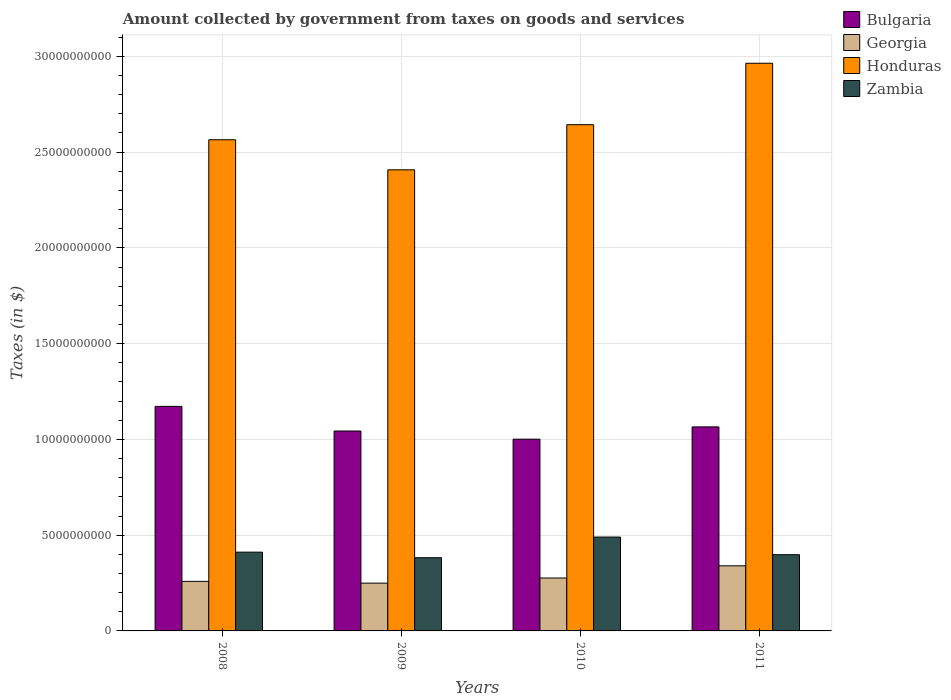How many different coloured bars are there?
Make the answer very short. 4. How many bars are there on the 4th tick from the left?
Offer a very short reply. 4. In how many cases, is the number of bars for a given year not equal to the number of legend labels?
Provide a succinct answer. 0. What is the amount collected by government from taxes on goods and services in Georgia in 2011?
Your answer should be very brief. 3.40e+09. Across all years, what is the maximum amount collected by government from taxes on goods and services in Zambia?
Offer a very short reply. 4.90e+09. Across all years, what is the minimum amount collected by government from taxes on goods and services in Honduras?
Ensure brevity in your answer.  2.41e+1. In which year was the amount collected by government from taxes on goods and services in Georgia maximum?
Keep it short and to the point. 2011. In which year was the amount collected by government from taxes on goods and services in Bulgaria minimum?
Provide a succinct answer. 2010. What is the total amount collected by government from taxes on goods and services in Bulgaria in the graph?
Your answer should be compact. 4.28e+1. What is the difference between the amount collected by government from taxes on goods and services in Honduras in 2008 and that in 2011?
Your response must be concise. -3.99e+09. What is the difference between the amount collected by government from taxes on goods and services in Honduras in 2011 and the amount collected by government from taxes on goods and services in Georgia in 2008?
Provide a succinct answer. 2.71e+1. What is the average amount collected by government from taxes on goods and services in Georgia per year?
Ensure brevity in your answer.  2.81e+09. In the year 2009, what is the difference between the amount collected by government from taxes on goods and services in Zambia and amount collected by government from taxes on goods and services in Bulgaria?
Your answer should be compact. -6.62e+09. In how many years, is the amount collected by government from taxes on goods and services in Georgia greater than 14000000000 $?
Ensure brevity in your answer.  0. What is the ratio of the amount collected by government from taxes on goods and services in Zambia in 2010 to that in 2011?
Make the answer very short. 1.23. What is the difference between the highest and the second highest amount collected by government from taxes on goods and services in Honduras?
Provide a succinct answer. 3.21e+09. What is the difference between the highest and the lowest amount collected by government from taxes on goods and services in Honduras?
Make the answer very short. 5.56e+09. Is it the case that in every year, the sum of the amount collected by government from taxes on goods and services in Georgia and amount collected by government from taxes on goods and services in Honduras is greater than the sum of amount collected by government from taxes on goods and services in Bulgaria and amount collected by government from taxes on goods and services in Zambia?
Provide a succinct answer. Yes. What does the 3rd bar from the left in 2011 represents?
Provide a short and direct response. Honduras. What does the 3rd bar from the right in 2011 represents?
Your response must be concise. Georgia. Is it the case that in every year, the sum of the amount collected by government from taxes on goods and services in Bulgaria and amount collected by government from taxes on goods and services in Georgia is greater than the amount collected by government from taxes on goods and services in Zambia?
Your response must be concise. Yes. Are all the bars in the graph horizontal?
Your answer should be very brief. No. How many years are there in the graph?
Offer a very short reply. 4. What is the difference between two consecutive major ticks on the Y-axis?
Provide a succinct answer. 5.00e+09. Does the graph contain any zero values?
Ensure brevity in your answer.  No. Where does the legend appear in the graph?
Give a very brief answer. Top right. How many legend labels are there?
Keep it short and to the point. 4. What is the title of the graph?
Offer a terse response. Amount collected by government from taxes on goods and services. What is the label or title of the Y-axis?
Give a very brief answer. Taxes (in $). What is the Taxes (in $) of Bulgaria in 2008?
Give a very brief answer. 1.17e+1. What is the Taxes (in $) of Georgia in 2008?
Your answer should be compact. 2.59e+09. What is the Taxes (in $) in Honduras in 2008?
Make the answer very short. 2.56e+1. What is the Taxes (in $) in Zambia in 2008?
Give a very brief answer. 4.11e+09. What is the Taxes (in $) in Bulgaria in 2009?
Offer a terse response. 1.04e+1. What is the Taxes (in $) of Georgia in 2009?
Your answer should be very brief. 2.49e+09. What is the Taxes (in $) of Honduras in 2009?
Your response must be concise. 2.41e+1. What is the Taxes (in $) of Zambia in 2009?
Your answer should be very brief. 3.82e+09. What is the Taxes (in $) in Bulgaria in 2010?
Make the answer very short. 1.00e+1. What is the Taxes (in $) of Georgia in 2010?
Offer a very short reply. 2.76e+09. What is the Taxes (in $) in Honduras in 2010?
Make the answer very short. 2.64e+1. What is the Taxes (in $) in Zambia in 2010?
Ensure brevity in your answer.  4.90e+09. What is the Taxes (in $) of Bulgaria in 2011?
Offer a very short reply. 1.07e+1. What is the Taxes (in $) in Georgia in 2011?
Your answer should be very brief. 3.40e+09. What is the Taxes (in $) of Honduras in 2011?
Keep it short and to the point. 2.96e+1. What is the Taxes (in $) in Zambia in 2011?
Ensure brevity in your answer.  3.98e+09. Across all years, what is the maximum Taxes (in $) in Bulgaria?
Give a very brief answer. 1.17e+1. Across all years, what is the maximum Taxes (in $) in Georgia?
Your response must be concise. 3.40e+09. Across all years, what is the maximum Taxes (in $) in Honduras?
Your answer should be very brief. 2.96e+1. Across all years, what is the maximum Taxes (in $) of Zambia?
Provide a succinct answer. 4.90e+09. Across all years, what is the minimum Taxes (in $) of Bulgaria?
Your answer should be compact. 1.00e+1. Across all years, what is the minimum Taxes (in $) of Georgia?
Ensure brevity in your answer.  2.49e+09. Across all years, what is the minimum Taxes (in $) of Honduras?
Make the answer very short. 2.41e+1. Across all years, what is the minimum Taxes (in $) of Zambia?
Offer a very short reply. 3.82e+09. What is the total Taxes (in $) of Bulgaria in the graph?
Keep it short and to the point. 4.28e+1. What is the total Taxes (in $) of Georgia in the graph?
Keep it short and to the point. 1.12e+1. What is the total Taxes (in $) in Honduras in the graph?
Ensure brevity in your answer.  1.06e+11. What is the total Taxes (in $) in Zambia in the graph?
Provide a short and direct response. 1.68e+1. What is the difference between the Taxes (in $) in Bulgaria in 2008 and that in 2009?
Keep it short and to the point. 1.29e+09. What is the difference between the Taxes (in $) of Georgia in 2008 and that in 2009?
Ensure brevity in your answer.  9.26e+07. What is the difference between the Taxes (in $) of Honduras in 2008 and that in 2009?
Offer a very short reply. 1.57e+09. What is the difference between the Taxes (in $) in Zambia in 2008 and that in 2009?
Give a very brief answer. 2.91e+08. What is the difference between the Taxes (in $) of Bulgaria in 2008 and that in 2010?
Provide a succinct answer. 1.71e+09. What is the difference between the Taxes (in $) in Georgia in 2008 and that in 2010?
Ensure brevity in your answer.  -1.76e+08. What is the difference between the Taxes (in $) in Honduras in 2008 and that in 2010?
Give a very brief answer. -7.85e+08. What is the difference between the Taxes (in $) of Zambia in 2008 and that in 2010?
Provide a short and direct response. -7.88e+08. What is the difference between the Taxes (in $) in Bulgaria in 2008 and that in 2011?
Your answer should be very brief. 1.07e+09. What is the difference between the Taxes (in $) in Georgia in 2008 and that in 2011?
Give a very brief answer. -8.12e+08. What is the difference between the Taxes (in $) in Honduras in 2008 and that in 2011?
Give a very brief answer. -3.99e+09. What is the difference between the Taxes (in $) in Zambia in 2008 and that in 2011?
Ensure brevity in your answer.  1.33e+08. What is the difference between the Taxes (in $) of Bulgaria in 2009 and that in 2010?
Your answer should be very brief. 4.26e+08. What is the difference between the Taxes (in $) of Georgia in 2009 and that in 2010?
Give a very brief answer. -2.69e+08. What is the difference between the Taxes (in $) of Honduras in 2009 and that in 2010?
Your answer should be very brief. -2.36e+09. What is the difference between the Taxes (in $) in Zambia in 2009 and that in 2010?
Your answer should be compact. -1.08e+09. What is the difference between the Taxes (in $) of Bulgaria in 2009 and that in 2011?
Provide a short and direct response. -2.15e+08. What is the difference between the Taxes (in $) in Georgia in 2009 and that in 2011?
Offer a very short reply. -9.05e+08. What is the difference between the Taxes (in $) in Honduras in 2009 and that in 2011?
Make the answer very short. -5.56e+09. What is the difference between the Taxes (in $) of Zambia in 2009 and that in 2011?
Ensure brevity in your answer.  -1.58e+08. What is the difference between the Taxes (in $) in Bulgaria in 2010 and that in 2011?
Ensure brevity in your answer.  -6.41e+08. What is the difference between the Taxes (in $) of Georgia in 2010 and that in 2011?
Keep it short and to the point. -6.36e+08. What is the difference between the Taxes (in $) of Honduras in 2010 and that in 2011?
Offer a terse response. -3.21e+09. What is the difference between the Taxes (in $) in Zambia in 2010 and that in 2011?
Keep it short and to the point. 9.21e+08. What is the difference between the Taxes (in $) in Bulgaria in 2008 and the Taxes (in $) in Georgia in 2009?
Provide a short and direct response. 9.23e+09. What is the difference between the Taxes (in $) of Bulgaria in 2008 and the Taxes (in $) of Honduras in 2009?
Your answer should be very brief. -1.24e+1. What is the difference between the Taxes (in $) in Bulgaria in 2008 and the Taxes (in $) in Zambia in 2009?
Your response must be concise. 7.90e+09. What is the difference between the Taxes (in $) of Georgia in 2008 and the Taxes (in $) of Honduras in 2009?
Make the answer very short. -2.15e+1. What is the difference between the Taxes (in $) of Georgia in 2008 and the Taxes (in $) of Zambia in 2009?
Keep it short and to the point. -1.23e+09. What is the difference between the Taxes (in $) of Honduras in 2008 and the Taxes (in $) of Zambia in 2009?
Give a very brief answer. 2.18e+1. What is the difference between the Taxes (in $) of Bulgaria in 2008 and the Taxes (in $) of Georgia in 2010?
Provide a succinct answer. 8.96e+09. What is the difference between the Taxes (in $) of Bulgaria in 2008 and the Taxes (in $) of Honduras in 2010?
Ensure brevity in your answer.  -1.47e+1. What is the difference between the Taxes (in $) of Bulgaria in 2008 and the Taxes (in $) of Zambia in 2010?
Keep it short and to the point. 6.82e+09. What is the difference between the Taxes (in $) of Georgia in 2008 and the Taxes (in $) of Honduras in 2010?
Your answer should be compact. -2.38e+1. What is the difference between the Taxes (in $) of Georgia in 2008 and the Taxes (in $) of Zambia in 2010?
Ensure brevity in your answer.  -2.31e+09. What is the difference between the Taxes (in $) in Honduras in 2008 and the Taxes (in $) in Zambia in 2010?
Provide a succinct answer. 2.07e+1. What is the difference between the Taxes (in $) in Bulgaria in 2008 and the Taxes (in $) in Georgia in 2011?
Keep it short and to the point. 8.32e+09. What is the difference between the Taxes (in $) of Bulgaria in 2008 and the Taxes (in $) of Honduras in 2011?
Keep it short and to the point. -1.79e+1. What is the difference between the Taxes (in $) in Bulgaria in 2008 and the Taxes (in $) in Zambia in 2011?
Ensure brevity in your answer.  7.74e+09. What is the difference between the Taxes (in $) of Georgia in 2008 and the Taxes (in $) of Honduras in 2011?
Your answer should be very brief. -2.71e+1. What is the difference between the Taxes (in $) in Georgia in 2008 and the Taxes (in $) in Zambia in 2011?
Make the answer very short. -1.39e+09. What is the difference between the Taxes (in $) in Honduras in 2008 and the Taxes (in $) in Zambia in 2011?
Your answer should be very brief. 2.17e+1. What is the difference between the Taxes (in $) of Bulgaria in 2009 and the Taxes (in $) of Georgia in 2010?
Give a very brief answer. 7.67e+09. What is the difference between the Taxes (in $) in Bulgaria in 2009 and the Taxes (in $) in Honduras in 2010?
Offer a very short reply. -1.60e+1. What is the difference between the Taxes (in $) in Bulgaria in 2009 and the Taxes (in $) in Zambia in 2010?
Make the answer very short. 5.54e+09. What is the difference between the Taxes (in $) in Georgia in 2009 and the Taxes (in $) in Honduras in 2010?
Offer a very short reply. -2.39e+1. What is the difference between the Taxes (in $) in Georgia in 2009 and the Taxes (in $) in Zambia in 2010?
Offer a very short reply. -2.41e+09. What is the difference between the Taxes (in $) in Honduras in 2009 and the Taxes (in $) in Zambia in 2010?
Provide a succinct answer. 1.92e+1. What is the difference between the Taxes (in $) in Bulgaria in 2009 and the Taxes (in $) in Georgia in 2011?
Provide a short and direct response. 7.04e+09. What is the difference between the Taxes (in $) in Bulgaria in 2009 and the Taxes (in $) in Honduras in 2011?
Provide a short and direct response. -1.92e+1. What is the difference between the Taxes (in $) of Bulgaria in 2009 and the Taxes (in $) of Zambia in 2011?
Offer a terse response. 6.46e+09. What is the difference between the Taxes (in $) of Georgia in 2009 and the Taxes (in $) of Honduras in 2011?
Ensure brevity in your answer.  -2.71e+1. What is the difference between the Taxes (in $) in Georgia in 2009 and the Taxes (in $) in Zambia in 2011?
Offer a terse response. -1.48e+09. What is the difference between the Taxes (in $) of Honduras in 2009 and the Taxes (in $) of Zambia in 2011?
Ensure brevity in your answer.  2.01e+1. What is the difference between the Taxes (in $) in Bulgaria in 2010 and the Taxes (in $) in Georgia in 2011?
Provide a short and direct response. 6.61e+09. What is the difference between the Taxes (in $) in Bulgaria in 2010 and the Taxes (in $) in Honduras in 2011?
Make the answer very short. -1.96e+1. What is the difference between the Taxes (in $) in Bulgaria in 2010 and the Taxes (in $) in Zambia in 2011?
Provide a succinct answer. 6.03e+09. What is the difference between the Taxes (in $) of Georgia in 2010 and the Taxes (in $) of Honduras in 2011?
Your response must be concise. -2.69e+1. What is the difference between the Taxes (in $) in Georgia in 2010 and the Taxes (in $) in Zambia in 2011?
Offer a very short reply. -1.22e+09. What is the difference between the Taxes (in $) in Honduras in 2010 and the Taxes (in $) in Zambia in 2011?
Your answer should be very brief. 2.25e+1. What is the average Taxes (in $) in Bulgaria per year?
Make the answer very short. 1.07e+1. What is the average Taxes (in $) in Georgia per year?
Offer a terse response. 2.81e+09. What is the average Taxes (in $) in Honduras per year?
Make the answer very short. 2.64e+1. What is the average Taxes (in $) of Zambia per year?
Your answer should be compact. 4.20e+09. In the year 2008, what is the difference between the Taxes (in $) in Bulgaria and Taxes (in $) in Georgia?
Provide a succinct answer. 9.14e+09. In the year 2008, what is the difference between the Taxes (in $) in Bulgaria and Taxes (in $) in Honduras?
Make the answer very short. -1.39e+1. In the year 2008, what is the difference between the Taxes (in $) in Bulgaria and Taxes (in $) in Zambia?
Offer a terse response. 7.61e+09. In the year 2008, what is the difference between the Taxes (in $) in Georgia and Taxes (in $) in Honduras?
Make the answer very short. -2.31e+1. In the year 2008, what is the difference between the Taxes (in $) of Georgia and Taxes (in $) of Zambia?
Give a very brief answer. -1.53e+09. In the year 2008, what is the difference between the Taxes (in $) in Honduras and Taxes (in $) in Zambia?
Offer a very short reply. 2.15e+1. In the year 2009, what is the difference between the Taxes (in $) in Bulgaria and Taxes (in $) in Georgia?
Offer a very short reply. 7.94e+09. In the year 2009, what is the difference between the Taxes (in $) of Bulgaria and Taxes (in $) of Honduras?
Your answer should be very brief. -1.36e+1. In the year 2009, what is the difference between the Taxes (in $) of Bulgaria and Taxes (in $) of Zambia?
Give a very brief answer. 6.62e+09. In the year 2009, what is the difference between the Taxes (in $) in Georgia and Taxes (in $) in Honduras?
Your answer should be compact. -2.16e+1. In the year 2009, what is the difference between the Taxes (in $) in Georgia and Taxes (in $) in Zambia?
Provide a succinct answer. -1.33e+09. In the year 2009, what is the difference between the Taxes (in $) in Honduras and Taxes (in $) in Zambia?
Your response must be concise. 2.03e+1. In the year 2010, what is the difference between the Taxes (in $) in Bulgaria and Taxes (in $) in Georgia?
Keep it short and to the point. 7.25e+09. In the year 2010, what is the difference between the Taxes (in $) of Bulgaria and Taxes (in $) of Honduras?
Your answer should be compact. -1.64e+1. In the year 2010, what is the difference between the Taxes (in $) of Bulgaria and Taxes (in $) of Zambia?
Your answer should be compact. 5.11e+09. In the year 2010, what is the difference between the Taxes (in $) of Georgia and Taxes (in $) of Honduras?
Provide a succinct answer. -2.37e+1. In the year 2010, what is the difference between the Taxes (in $) of Georgia and Taxes (in $) of Zambia?
Your response must be concise. -2.14e+09. In the year 2010, what is the difference between the Taxes (in $) in Honduras and Taxes (in $) in Zambia?
Make the answer very short. 2.15e+1. In the year 2011, what is the difference between the Taxes (in $) of Bulgaria and Taxes (in $) of Georgia?
Give a very brief answer. 7.25e+09. In the year 2011, what is the difference between the Taxes (in $) in Bulgaria and Taxes (in $) in Honduras?
Offer a very short reply. -1.90e+1. In the year 2011, what is the difference between the Taxes (in $) in Bulgaria and Taxes (in $) in Zambia?
Make the answer very short. 6.67e+09. In the year 2011, what is the difference between the Taxes (in $) in Georgia and Taxes (in $) in Honduras?
Provide a succinct answer. -2.62e+1. In the year 2011, what is the difference between the Taxes (in $) of Georgia and Taxes (in $) of Zambia?
Offer a terse response. -5.80e+08. In the year 2011, what is the difference between the Taxes (in $) of Honduras and Taxes (in $) of Zambia?
Your answer should be very brief. 2.57e+1. What is the ratio of the Taxes (in $) in Bulgaria in 2008 to that in 2009?
Your answer should be compact. 1.12. What is the ratio of the Taxes (in $) of Georgia in 2008 to that in 2009?
Ensure brevity in your answer.  1.04. What is the ratio of the Taxes (in $) of Honduras in 2008 to that in 2009?
Make the answer very short. 1.07. What is the ratio of the Taxes (in $) of Zambia in 2008 to that in 2009?
Provide a short and direct response. 1.08. What is the ratio of the Taxes (in $) in Bulgaria in 2008 to that in 2010?
Offer a terse response. 1.17. What is the ratio of the Taxes (in $) in Georgia in 2008 to that in 2010?
Keep it short and to the point. 0.94. What is the ratio of the Taxes (in $) in Honduras in 2008 to that in 2010?
Make the answer very short. 0.97. What is the ratio of the Taxes (in $) of Zambia in 2008 to that in 2010?
Make the answer very short. 0.84. What is the ratio of the Taxes (in $) in Bulgaria in 2008 to that in 2011?
Offer a terse response. 1.1. What is the ratio of the Taxes (in $) of Georgia in 2008 to that in 2011?
Your answer should be compact. 0.76. What is the ratio of the Taxes (in $) of Honduras in 2008 to that in 2011?
Provide a short and direct response. 0.87. What is the ratio of the Taxes (in $) in Zambia in 2008 to that in 2011?
Provide a short and direct response. 1.03. What is the ratio of the Taxes (in $) in Bulgaria in 2009 to that in 2010?
Provide a succinct answer. 1.04. What is the ratio of the Taxes (in $) in Georgia in 2009 to that in 2010?
Your answer should be compact. 0.9. What is the ratio of the Taxes (in $) of Honduras in 2009 to that in 2010?
Offer a very short reply. 0.91. What is the ratio of the Taxes (in $) in Zambia in 2009 to that in 2010?
Your answer should be very brief. 0.78. What is the ratio of the Taxes (in $) in Bulgaria in 2009 to that in 2011?
Your answer should be very brief. 0.98. What is the ratio of the Taxes (in $) of Georgia in 2009 to that in 2011?
Keep it short and to the point. 0.73. What is the ratio of the Taxes (in $) in Honduras in 2009 to that in 2011?
Your response must be concise. 0.81. What is the ratio of the Taxes (in $) in Zambia in 2009 to that in 2011?
Provide a short and direct response. 0.96. What is the ratio of the Taxes (in $) of Bulgaria in 2010 to that in 2011?
Offer a very short reply. 0.94. What is the ratio of the Taxes (in $) in Georgia in 2010 to that in 2011?
Your response must be concise. 0.81. What is the ratio of the Taxes (in $) of Honduras in 2010 to that in 2011?
Provide a succinct answer. 0.89. What is the ratio of the Taxes (in $) in Zambia in 2010 to that in 2011?
Your answer should be very brief. 1.23. What is the difference between the highest and the second highest Taxes (in $) in Bulgaria?
Ensure brevity in your answer.  1.07e+09. What is the difference between the highest and the second highest Taxes (in $) in Georgia?
Your answer should be compact. 6.36e+08. What is the difference between the highest and the second highest Taxes (in $) of Honduras?
Ensure brevity in your answer.  3.21e+09. What is the difference between the highest and the second highest Taxes (in $) in Zambia?
Provide a short and direct response. 7.88e+08. What is the difference between the highest and the lowest Taxes (in $) of Bulgaria?
Make the answer very short. 1.71e+09. What is the difference between the highest and the lowest Taxes (in $) of Georgia?
Ensure brevity in your answer.  9.05e+08. What is the difference between the highest and the lowest Taxes (in $) of Honduras?
Provide a succinct answer. 5.56e+09. What is the difference between the highest and the lowest Taxes (in $) in Zambia?
Give a very brief answer. 1.08e+09. 